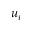Convert formula to latex. <formula><loc_0><loc_0><loc_500><loc_500>u _ { i }</formula> 